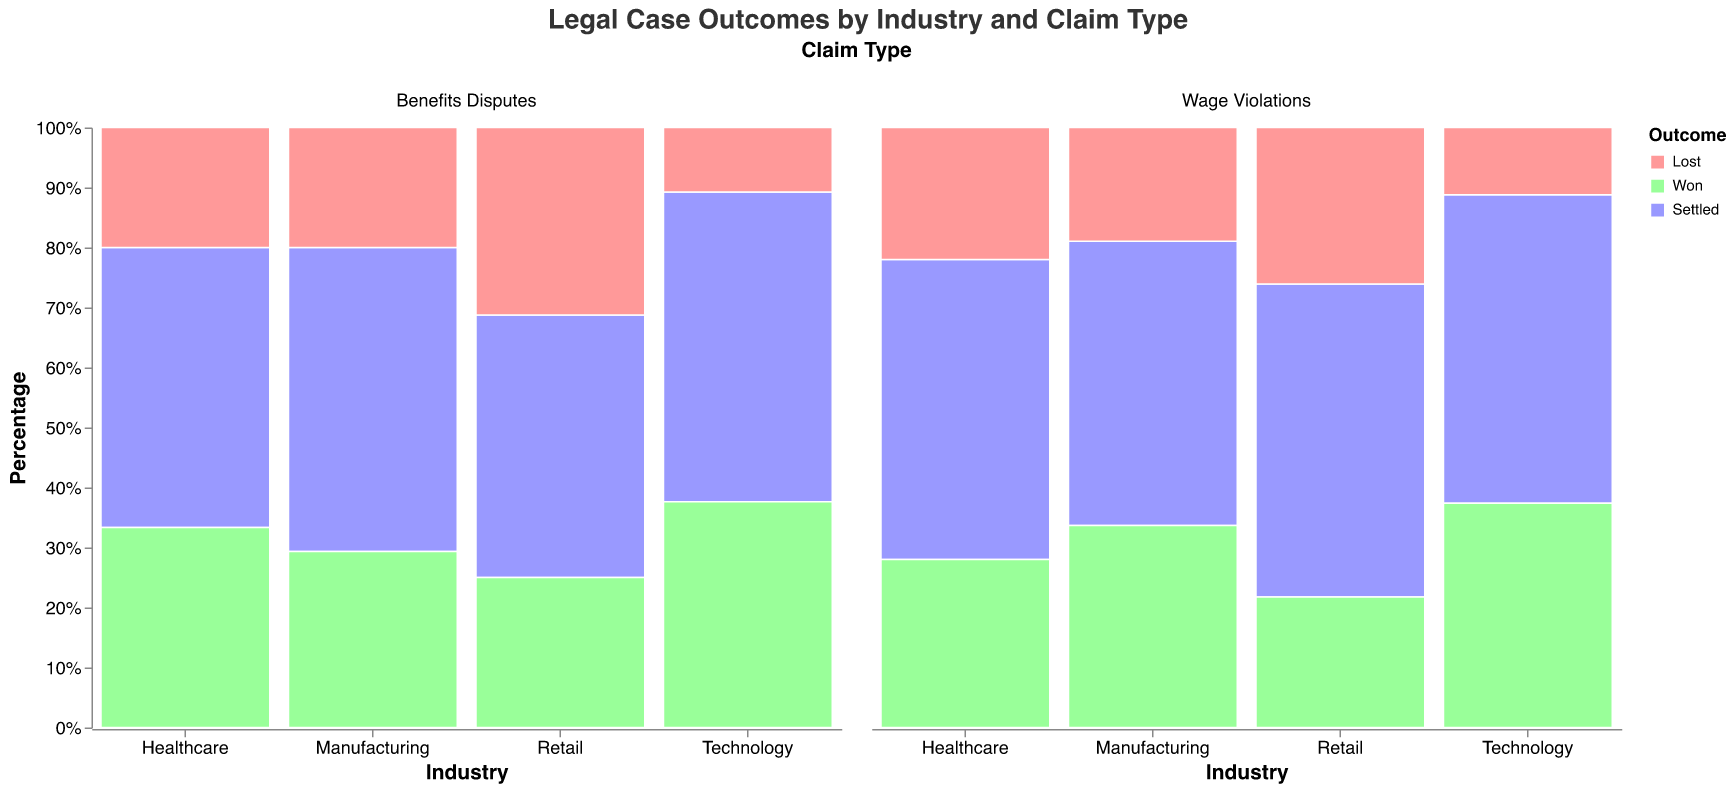What's the title of the figure? The title is displayed at the top center of the chart. It reads "Legal Case Outcomes by Industry and Claim Type".
Answer: Legal Case Outcomes by Industry and Claim Type In which industry do "Wage Violations" have the highest percentage of cases won? By looking at the "Wage Violations" column and comparing the height of the "Won" segments across industries, Technology has the highest percentage of cases won.
Answer: Technology How does the percentage of settled cases for "Benefits Disputes" in Retail compare to Technology? You need to compare the "Settled" segments within the "Benefits Disputes" columns for Retail and Technology. Retail has a lower percentage of settled cases than Technology.
Answer: Technology has a higher percentage Which industry has the lowest percentage of lost cases for "Wage Violations"? Look at the "Wage Violations" column and observe the height of the "Lost" segments. Technology has the smallest segment for lost cases.
Answer: Technology What is the percentage of won cases in the Healthcare industry for "Benefits Disputes"? Find the "Benefits Disputes" column for Healthcare and look at the "Won" segment's height. The tooltip or y-axis is not directly specific, but judging visually, it's closest to 30%.
Answer: 30% Sort industries by the total percentage of lost cases across all claim types in descending order. Sum the percentages of lost cases for both "Wage Violations" and "Benefits Disputes" for each industry and order them. Retail has the highest, followed by Healthcare, Manufacturing, and Technology.
Answer: Retail, Healthcare, Manufacturing, Technology What is the difference in the percentage of won cases between "Wage Violations" and "Benefits Disputes" in Manufacturing? Observe the "Won" segments in Manufacturing for both claim types. Subtract the percentage in "Benefits Disputes" from "Wage Violations." Approximately, the difference is (45% - 22% = 23%).
Answer: 23% Which outcome is most common for the "Benefits Disputes" in the Technology industry? Look at the "Benefits Disputes" column for Technology and compare the segments' heights. The largest segment indicates the most common outcome, which is "Settled".
Answer: Settled What claim type in Healthcare has the higher percentage of lost cases? Compare the "Lost" segments in the Healthcare industry for both claim types. "Wage Violations" has a higher percentage of lost cases compared to "Benefits Disputes".
Answer: Wage Violations 